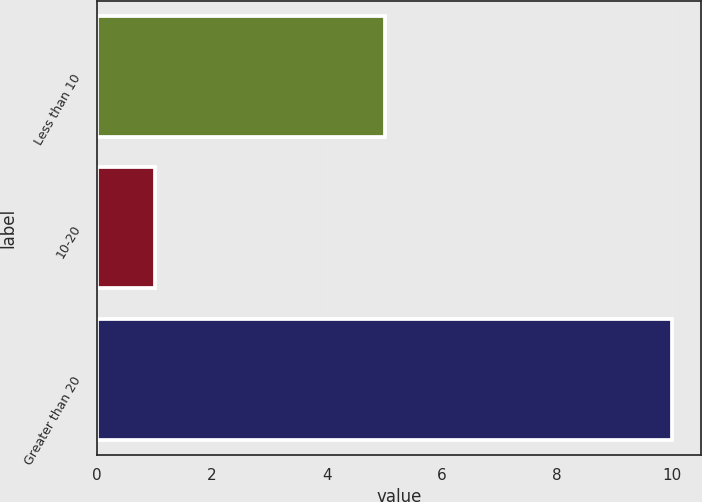<chart> <loc_0><loc_0><loc_500><loc_500><bar_chart><fcel>Less than 10<fcel>10-20<fcel>Greater than 20<nl><fcel>5<fcel>1<fcel>10<nl></chart> 